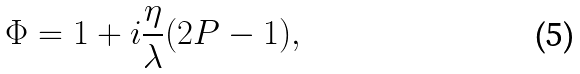<formula> <loc_0><loc_0><loc_500><loc_500>\Phi = 1 + i \frac { \eta } { \lambda } ( 2 P - 1 ) ,</formula> 